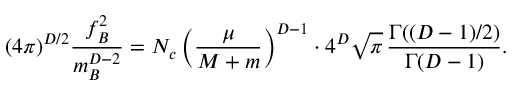<formula> <loc_0><loc_0><loc_500><loc_500>( 4 \pi ) ^ { D / 2 } \frac { f _ { B } ^ { 2 } } { m _ { B } ^ { D - 2 } } = N _ { c } \left ( \frac { \mu } { M + m } \right ) ^ { D - 1 } \cdot 4 ^ { D } \sqrt { \pi } \, \frac { \Gamma ( ( D - 1 ) / 2 ) } { \Gamma ( D - 1 ) } .</formula> 